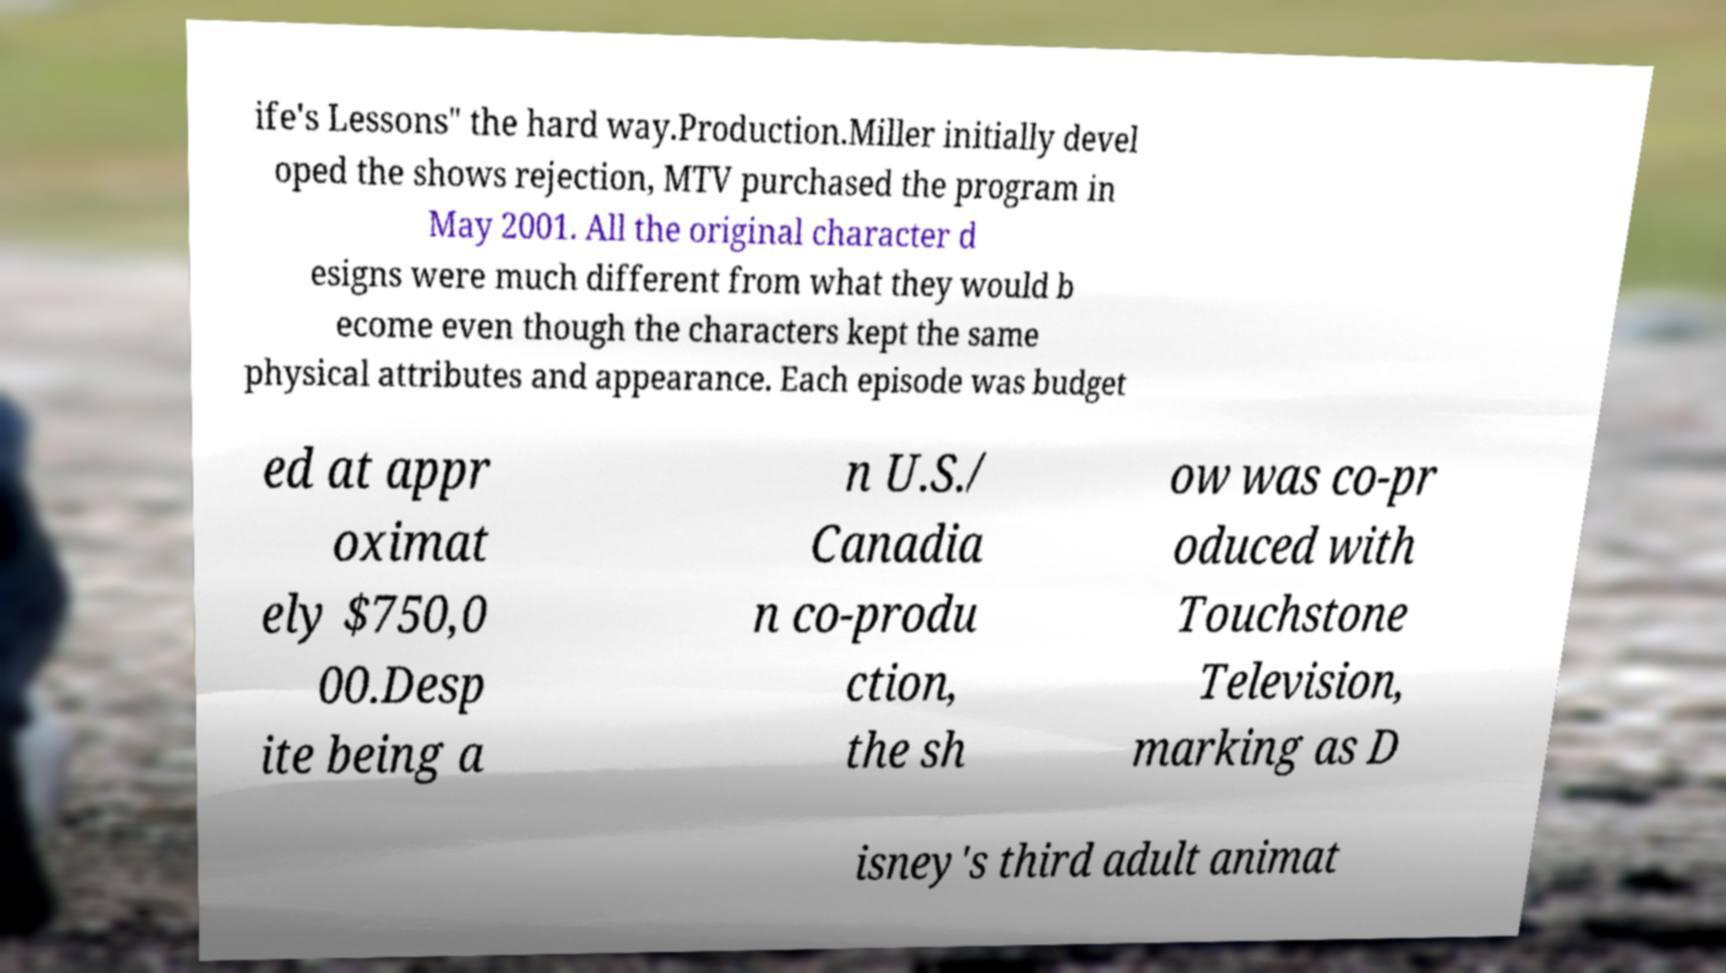Can you accurately transcribe the text from the provided image for me? ife's Lessons" the hard way.Production.Miller initially devel oped the shows rejection, MTV purchased the program in May 2001. All the original character d esigns were much different from what they would b ecome even though the characters kept the same physical attributes and appearance. Each episode was budget ed at appr oximat ely $750,0 00.Desp ite being a n U.S./ Canadia n co-produ ction, the sh ow was co-pr oduced with Touchstone Television, marking as D isney's third adult animat 